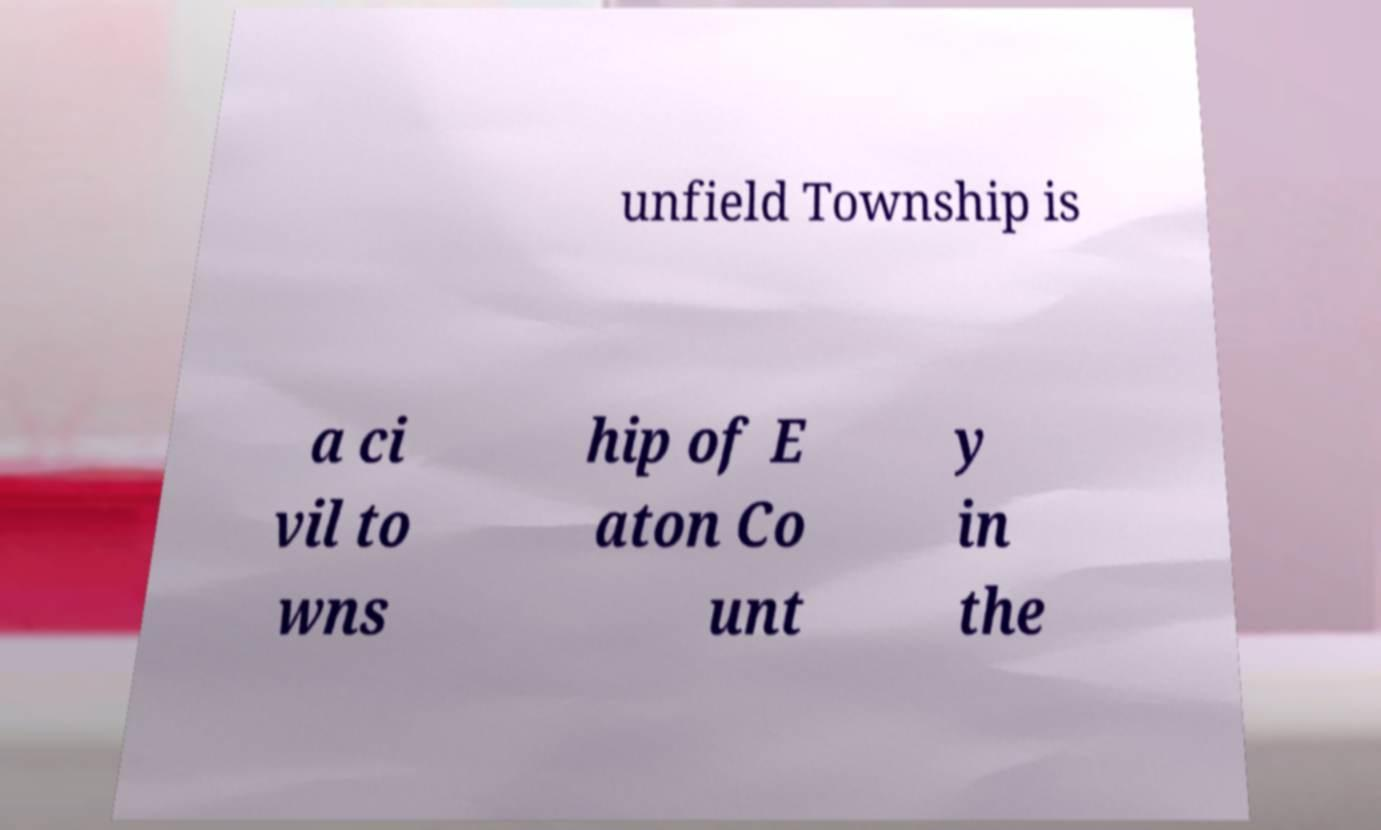Please read and relay the text visible in this image. What does it say? unfield Township is a ci vil to wns hip of E aton Co unt y in the 